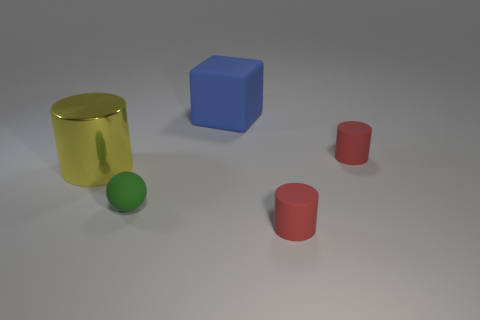Can you describe the colors and shapes visible in the image? Certainly! In the image, there is a variety of colors and shapes. We see a transparent yellow cylinder, a solid blue cube, a green matte ball, and two red cylinders. The assortment provides a simple yet visually engaging representation of basic geometric shapes and primary colors. 